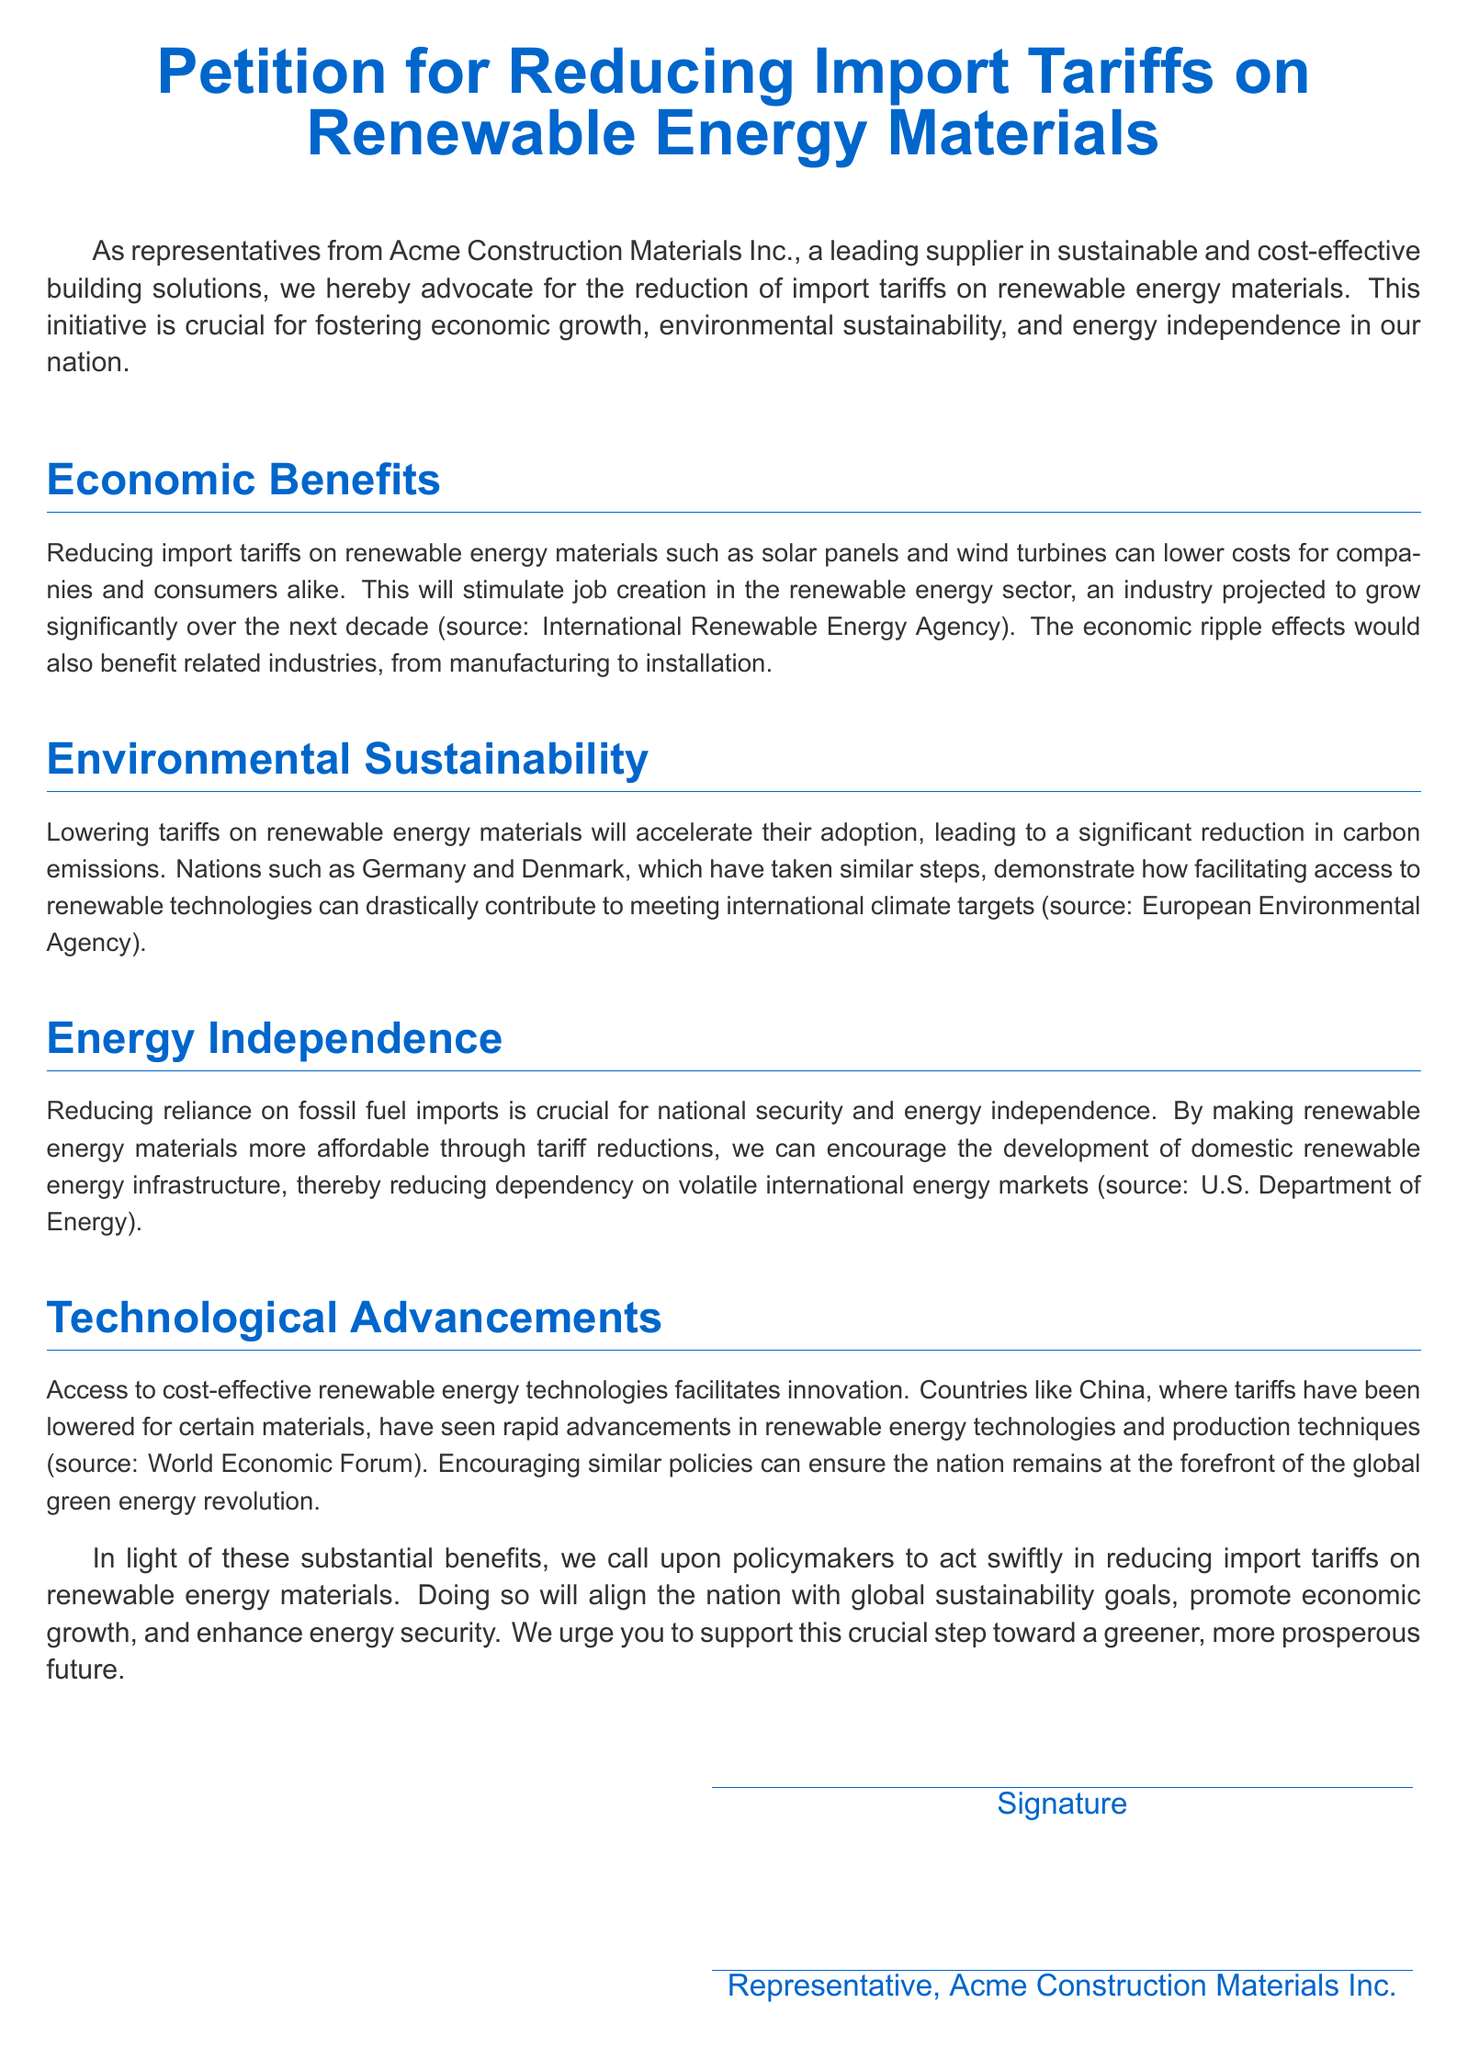what is the title of the petition? The title is the main subject of the petition outlined at the top of the document, which reflects its primary advocacy.
Answer: Petition for Reducing Import Tariffs on Renewable Energy Materials who is the representative of the petition? The document specifies the name of the representative who signed as a representative of their company, indicating the entity supporting the petition.
Answer: Representative, Acme Construction Materials Inc what is one of the economic benefits mentioned? The document states various economic benefits related to reducing tariffs, which include lower costs for different groups involved in renewable energy.
Answer: Job creation which nation's example is given for successful tariff reduction? The petition cites specific countries that have lowered tariffs on renewable energy materials and realized positive results.
Answer: Germany what is the primary goal regarding energy independence mentioned in the document? The petition aims to highlight a significant aspect of national energy strategies by focusing on the benefits of reducing reliance on external energy sources.
Answer: Reduce dependency on fossil fuel imports how does the petition characterize the current renewable energy sector? The document describes the renewable energy sector as having substantial growth potential, which is crucial for local economic activity and job generation.
Answer: Projected to grow significantly which governmental department is referenced for information on energy independence? The document includes information from an authoritative governmental source to support its statements about energy independence and policy proposals.
Answer: U.S. Department of Energy what type of materials does the petition specifically advocate to reduce tariffs on? The document clearly specifies the focus on particular materials related to renewable energy technologies and their tariffs.
Answer: Renewable energy materials 